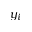<formula> <loc_0><loc_0><loc_500><loc_500>y _ { i }</formula> 